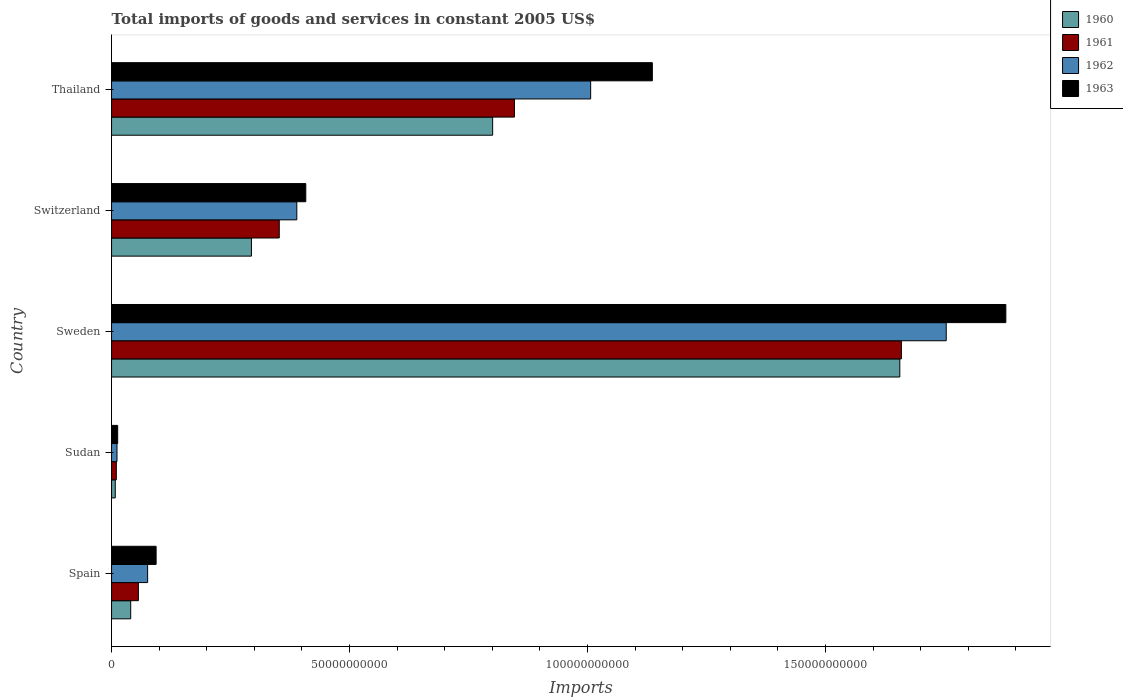How many different coloured bars are there?
Your answer should be very brief. 4. How many groups of bars are there?
Your answer should be compact. 5. Are the number of bars on each tick of the Y-axis equal?
Your response must be concise. Yes. How many bars are there on the 4th tick from the bottom?
Make the answer very short. 4. What is the label of the 1st group of bars from the top?
Your answer should be very brief. Thailand. What is the total imports of goods and services in 1960 in Sweden?
Offer a very short reply. 1.66e+11. Across all countries, what is the maximum total imports of goods and services in 1963?
Ensure brevity in your answer.  1.88e+11. Across all countries, what is the minimum total imports of goods and services in 1961?
Offer a very short reply. 1.00e+09. In which country was the total imports of goods and services in 1960 maximum?
Ensure brevity in your answer.  Sweden. In which country was the total imports of goods and services in 1961 minimum?
Keep it short and to the point. Sudan. What is the total total imports of goods and services in 1963 in the graph?
Offer a terse response. 3.53e+11. What is the difference between the total imports of goods and services in 1960 in Spain and that in Sudan?
Your answer should be compact. 3.24e+09. What is the difference between the total imports of goods and services in 1962 in Sudan and the total imports of goods and services in 1960 in Switzerland?
Ensure brevity in your answer.  -2.82e+1. What is the average total imports of goods and services in 1962 per country?
Your answer should be very brief. 6.47e+1. What is the difference between the total imports of goods and services in 1962 and total imports of goods and services in 1963 in Thailand?
Keep it short and to the point. -1.30e+1. In how many countries, is the total imports of goods and services in 1960 greater than 160000000000 US$?
Your response must be concise. 1. What is the ratio of the total imports of goods and services in 1963 in Sweden to that in Thailand?
Keep it short and to the point. 1.65. What is the difference between the highest and the second highest total imports of goods and services in 1962?
Make the answer very short. 7.47e+1. What is the difference between the highest and the lowest total imports of goods and services in 1963?
Your response must be concise. 1.87e+11. In how many countries, is the total imports of goods and services in 1960 greater than the average total imports of goods and services in 1960 taken over all countries?
Keep it short and to the point. 2. Is it the case that in every country, the sum of the total imports of goods and services in 1961 and total imports of goods and services in 1960 is greater than the sum of total imports of goods and services in 1963 and total imports of goods and services in 1962?
Offer a very short reply. No. How many bars are there?
Ensure brevity in your answer.  20. Are the values on the major ticks of X-axis written in scientific E-notation?
Keep it short and to the point. No. Does the graph contain any zero values?
Keep it short and to the point. No. Where does the legend appear in the graph?
Your response must be concise. Top right. How are the legend labels stacked?
Make the answer very short. Vertical. What is the title of the graph?
Provide a short and direct response. Total imports of goods and services in constant 2005 US$. What is the label or title of the X-axis?
Keep it short and to the point. Imports. What is the Imports in 1960 in Spain?
Make the answer very short. 4.02e+09. What is the Imports of 1961 in Spain?
Keep it short and to the point. 5.64e+09. What is the Imports of 1962 in Spain?
Ensure brevity in your answer.  7.58e+09. What is the Imports of 1963 in Spain?
Your answer should be compact. 9.36e+09. What is the Imports of 1960 in Sudan?
Give a very brief answer. 7.79e+08. What is the Imports of 1961 in Sudan?
Your response must be concise. 1.00e+09. What is the Imports of 1962 in Sudan?
Offer a very short reply. 1.14e+09. What is the Imports of 1963 in Sudan?
Offer a very short reply. 1.28e+09. What is the Imports in 1960 in Sweden?
Give a very brief answer. 1.66e+11. What is the Imports in 1961 in Sweden?
Keep it short and to the point. 1.66e+11. What is the Imports of 1962 in Sweden?
Your answer should be very brief. 1.75e+11. What is the Imports of 1963 in Sweden?
Give a very brief answer. 1.88e+11. What is the Imports in 1960 in Switzerland?
Make the answer very short. 2.94e+1. What is the Imports of 1961 in Switzerland?
Your answer should be compact. 3.52e+1. What is the Imports of 1962 in Switzerland?
Make the answer very short. 3.89e+1. What is the Imports of 1963 in Switzerland?
Your response must be concise. 4.08e+1. What is the Imports in 1960 in Thailand?
Ensure brevity in your answer.  8.01e+1. What is the Imports of 1961 in Thailand?
Offer a terse response. 8.46e+1. What is the Imports in 1962 in Thailand?
Make the answer very short. 1.01e+11. What is the Imports in 1963 in Thailand?
Your response must be concise. 1.14e+11. Across all countries, what is the maximum Imports in 1960?
Provide a succinct answer. 1.66e+11. Across all countries, what is the maximum Imports of 1961?
Ensure brevity in your answer.  1.66e+11. Across all countries, what is the maximum Imports of 1962?
Ensure brevity in your answer.  1.75e+11. Across all countries, what is the maximum Imports in 1963?
Offer a terse response. 1.88e+11. Across all countries, what is the minimum Imports of 1960?
Your answer should be compact. 7.79e+08. Across all countries, what is the minimum Imports in 1961?
Offer a very short reply. 1.00e+09. Across all countries, what is the minimum Imports in 1962?
Make the answer very short. 1.14e+09. Across all countries, what is the minimum Imports in 1963?
Your answer should be very brief. 1.28e+09. What is the total Imports of 1960 in the graph?
Offer a very short reply. 2.80e+11. What is the total Imports in 1961 in the graph?
Offer a terse response. 2.92e+11. What is the total Imports of 1962 in the graph?
Provide a succinct answer. 3.24e+11. What is the total Imports in 1963 in the graph?
Provide a succinct answer. 3.53e+11. What is the difference between the Imports in 1960 in Spain and that in Sudan?
Keep it short and to the point. 3.24e+09. What is the difference between the Imports in 1961 in Spain and that in Sudan?
Your answer should be compact. 4.63e+09. What is the difference between the Imports in 1962 in Spain and that in Sudan?
Your answer should be very brief. 6.44e+09. What is the difference between the Imports in 1963 in Spain and that in Sudan?
Give a very brief answer. 8.08e+09. What is the difference between the Imports of 1960 in Spain and that in Sweden?
Your response must be concise. -1.62e+11. What is the difference between the Imports of 1961 in Spain and that in Sweden?
Provide a succinct answer. -1.60e+11. What is the difference between the Imports of 1962 in Spain and that in Sweden?
Ensure brevity in your answer.  -1.68e+11. What is the difference between the Imports of 1963 in Spain and that in Sweden?
Offer a terse response. -1.79e+11. What is the difference between the Imports in 1960 in Spain and that in Switzerland?
Offer a terse response. -2.54e+1. What is the difference between the Imports of 1961 in Spain and that in Switzerland?
Offer a very short reply. -2.96e+1. What is the difference between the Imports of 1962 in Spain and that in Switzerland?
Make the answer very short. -3.13e+1. What is the difference between the Imports of 1963 in Spain and that in Switzerland?
Give a very brief answer. -3.14e+1. What is the difference between the Imports in 1960 in Spain and that in Thailand?
Provide a short and direct response. -7.60e+1. What is the difference between the Imports of 1961 in Spain and that in Thailand?
Offer a terse response. -7.90e+1. What is the difference between the Imports of 1962 in Spain and that in Thailand?
Offer a very short reply. -9.31e+1. What is the difference between the Imports of 1963 in Spain and that in Thailand?
Your answer should be compact. -1.04e+11. What is the difference between the Imports in 1960 in Sudan and that in Sweden?
Provide a succinct answer. -1.65e+11. What is the difference between the Imports of 1961 in Sudan and that in Sweden?
Offer a very short reply. -1.65e+11. What is the difference between the Imports in 1962 in Sudan and that in Sweden?
Keep it short and to the point. -1.74e+11. What is the difference between the Imports of 1963 in Sudan and that in Sweden?
Provide a succinct answer. -1.87e+11. What is the difference between the Imports in 1960 in Sudan and that in Switzerland?
Your response must be concise. -2.86e+1. What is the difference between the Imports in 1961 in Sudan and that in Switzerland?
Make the answer very short. -3.42e+1. What is the difference between the Imports in 1962 in Sudan and that in Switzerland?
Your answer should be compact. -3.78e+1. What is the difference between the Imports of 1963 in Sudan and that in Switzerland?
Your answer should be very brief. -3.95e+1. What is the difference between the Imports in 1960 in Sudan and that in Thailand?
Keep it short and to the point. -7.93e+1. What is the difference between the Imports of 1961 in Sudan and that in Thailand?
Offer a terse response. -8.36e+1. What is the difference between the Imports of 1962 in Sudan and that in Thailand?
Your answer should be compact. -9.95e+1. What is the difference between the Imports of 1963 in Sudan and that in Thailand?
Offer a terse response. -1.12e+11. What is the difference between the Imports of 1960 in Sweden and that in Switzerland?
Give a very brief answer. 1.36e+11. What is the difference between the Imports of 1961 in Sweden and that in Switzerland?
Offer a terse response. 1.31e+11. What is the difference between the Imports of 1962 in Sweden and that in Switzerland?
Offer a very short reply. 1.36e+11. What is the difference between the Imports of 1963 in Sweden and that in Switzerland?
Provide a succinct answer. 1.47e+11. What is the difference between the Imports in 1960 in Sweden and that in Thailand?
Ensure brevity in your answer.  8.55e+1. What is the difference between the Imports in 1961 in Sweden and that in Thailand?
Make the answer very short. 8.13e+1. What is the difference between the Imports of 1962 in Sweden and that in Thailand?
Your answer should be very brief. 7.47e+1. What is the difference between the Imports of 1963 in Sweden and that in Thailand?
Give a very brief answer. 7.43e+1. What is the difference between the Imports of 1960 in Switzerland and that in Thailand?
Your answer should be very brief. -5.07e+1. What is the difference between the Imports in 1961 in Switzerland and that in Thailand?
Your answer should be very brief. -4.94e+1. What is the difference between the Imports in 1962 in Switzerland and that in Thailand?
Your answer should be very brief. -6.17e+1. What is the difference between the Imports of 1963 in Switzerland and that in Thailand?
Your answer should be very brief. -7.28e+1. What is the difference between the Imports in 1960 in Spain and the Imports in 1961 in Sudan?
Provide a succinct answer. 3.02e+09. What is the difference between the Imports in 1960 in Spain and the Imports in 1962 in Sudan?
Keep it short and to the point. 2.88e+09. What is the difference between the Imports in 1960 in Spain and the Imports in 1963 in Sudan?
Keep it short and to the point. 2.74e+09. What is the difference between the Imports in 1961 in Spain and the Imports in 1962 in Sudan?
Your answer should be very brief. 4.49e+09. What is the difference between the Imports of 1961 in Spain and the Imports of 1963 in Sudan?
Ensure brevity in your answer.  4.35e+09. What is the difference between the Imports in 1962 in Spain and the Imports in 1963 in Sudan?
Provide a short and direct response. 6.30e+09. What is the difference between the Imports of 1960 in Spain and the Imports of 1961 in Sweden?
Your answer should be compact. -1.62e+11. What is the difference between the Imports of 1960 in Spain and the Imports of 1962 in Sweden?
Offer a terse response. -1.71e+11. What is the difference between the Imports of 1960 in Spain and the Imports of 1963 in Sweden?
Your response must be concise. -1.84e+11. What is the difference between the Imports of 1961 in Spain and the Imports of 1962 in Sweden?
Offer a terse response. -1.70e+11. What is the difference between the Imports in 1961 in Spain and the Imports in 1963 in Sweden?
Give a very brief answer. -1.82e+11. What is the difference between the Imports in 1962 in Spain and the Imports in 1963 in Sweden?
Keep it short and to the point. -1.80e+11. What is the difference between the Imports of 1960 in Spain and the Imports of 1961 in Switzerland?
Provide a succinct answer. -3.12e+1. What is the difference between the Imports in 1960 in Spain and the Imports in 1962 in Switzerland?
Give a very brief answer. -3.49e+1. What is the difference between the Imports of 1960 in Spain and the Imports of 1963 in Switzerland?
Offer a very short reply. -3.68e+1. What is the difference between the Imports in 1961 in Spain and the Imports in 1962 in Switzerland?
Offer a terse response. -3.33e+1. What is the difference between the Imports of 1961 in Spain and the Imports of 1963 in Switzerland?
Make the answer very short. -3.52e+1. What is the difference between the Imports in 1962 in Spain and the Imports in 1963 in Switzerland?
Ensure brevity in your answer.  -3.32e+1. What is the difference between the Imports in 1960 in Spain and the Imports in 1961 in Thailand?
Offer a terse response. -8.06e+1. What is the difference between the Imports in 1960 in Spain and the Imports in 1962 in Thailand?
Your response must be concise. -9.66e+1. What is the difference between the Imports of 1960 in Spain and the Imports of 1963 in Thailand?
Ensure brevity in your answer.  -1.10e+11. What is the difference between the Imports in 1961 in Spain and the Imports in 1962 in Thailand?
Ensure brevity in your answer.  -9.50e+1. What is the difference between the Imports in 1961 in Spain and the Imports in 1963 in Thailand?
Ensure brevity in your answer.  -1.08e+11. What is the difference between the Imports in 1962 in Spain and the Imports in 1963 in Thailand?
Make the answer very short. -1.06e+11. What is the difference between the Imports in 1960 in Sudan and the Imports in 1961 in Sweden?
Your answer should be compact. -1.65e+11. What is the difference between the Imports in 1960 in Sudan and the Imports in 1962 in Sweden?
Make the answer very short. -1.75e+11. What is the difference between the Imports in 1960 in Sudan and the Imports in 1963 in Sweden?
Keep it short and to the point. -1.87e+11. What is the difference between the Imports in 1961 in Sudan and the Imports in 1962 in Sweden?
Give a very brief answer. -1.74e+11. What is the difference between the Imports in 1961 in Sudan and the Imports in 1963 in Sweden?
Your answer should be compact. -1.87e+11. What is the difference between the Imports of 1962 in Sudan and the Imports of 1963 in Sweden?
Give a very brief answer. -1.87e+11. What is the difference between the Imports of 1960 in Sudan and the Imports of 1961 in Switzerland?
Offer a very short reply. -3.45e+1. What is the difference between the Imports of 1960 in Sudan and the Imports of 1962 in Switzerland?
Provide a succinct answer. -3.81e+1. What is the difference between the Imports in 1960 in Sudan and the Imports in 1963 in Switzerland?
Your answer should be compact. -4.00e+1. What is the difference between the Imports of 1961 in Sudan and the Imports of 1962 in Switzerland?
Provide a short and direct response. -3.79e+1. What is the difference between the Imports of 1961 in Sudan and the Imports of 1963 in Switzerland?
Provide a short and direct response. -3.98e+1. What is the difference between the Imports of 1962 in Sudan and the Imports of 1963 in Switzerland?
Your answer should be very brief. -3.97e+1. What is the difference between the Imports of 1960 in Sudan and the Imports of 1961 in Thailand?
Keep it short and to the point. -8.39e+1. What is the difference between the Imports in 1960 in Sudan and the Imports in 1962 in Thailand?
Provide a short and direct response. -9.99e+1. What is the difference between the Imports of 1960 in Sudan and the Imports of 1963 in Thailand?
Ensure brevity in your answer.  -1.13e+11. What is the difference between the Imports in 1961 in Sudan and the Imports in 1962 in Thailand?
Offer a terse response. -9.97e+1. What is the difference between the Imports in 1961 in Sudan and the Imports in 1963 in Thailand?
Your response must be concise. -1.13e+11. What is the difference between the Imports in 1962 in Sudan and the Imports in 1963 in Thailand?
Provide a short and direct response. -1.12e+11. What is the difference between the Imports in 1960 in Sweden and the Imports in 1961 in Switzerland?
Offer a very short reply. 1.30e+11. What is the difference between the Imports in 1960 in Sweden and the Imports in 1962 in Switzerland?
Your answer should be compact. 1.27e+11. What is the difference between the Imports of 1960 in Sweden and the Imports of 1963 in Switzerland?
Your answer should be very brief. 1.25e+11. What is the difference between the Imports in 1961 in Sweden and the Imports in 1962 in Switzerland?
Make the answer very short. 1.27e+11. What is the difference between the Imports in 1961 in Sweden and the Imports in 1963 in Switzerland?
Your answer should be very brief. 1.25e+11. What is the difference between the Imports of 1962 in Sweden and the Imports of 1963 in Switzerland?
Your response must be concise. 1.35e+11. What is the difference between the Imports in 1960 in Sweden and the Imports in 1961 in Thailand?
Provide a succinct answer. 8.10e+1. What is the difference between the Imports of 1960 in Sweden and the Imports of 1962 in Thailand?
Your answer should be very brief. 6.50e+1. What is the difference between the Imports in 1960 in Sweden and the Imports in 1963 in Thailand?
Your answer should be very brief. 5.20e+1. What is the difference between the Imports in 1961 in Sweden and the Imports in 1962 in Thailand?
Offer a terse response. 6.53e+1. What is the difference between the Imports in 1961 in Sweden and the Imports in 1963 in Thailand?
Give a very brief answer. 5.23e+1. What is the difference between the Imports of 1962 in Sweden and the Imports of 1963 in Thailand?
Your answer should be very brief. 6.17e+1. What is the difference between the Imports in 1960 in Switzerland and the Imports in 1961 in Thailand?
Make the answer very short. -5.53e+1. What is the difference between the Imports in 1960 in Switzerland and the Imports in 1962 in Thailand?
Provide a succinct answer. -7.13e+1. What is the difference between the Imports in 1960 in Switzerland and the Imports in 1963 in Thailand?
Offer a very short reply. -8.42e+1. What is the difference between the Imports of 1961 in Switzerland and the Imports of 1962 in Thailand?
Provide a short and direct response. -6.54e+1. What is the difference between the Imports of 1961 in Switzerland and the Imports of 1963 in Thailand?
Make the answer very short. -7.84e+1. What is the difference between the Imports of 1962 in Switzerland and the Imports of 1963 in Thailand?
Your answer should be very brief. -7.47e+1. What is the average Imports of 1960 per country?
Offer a terse response. 5.60e+1. What is the average Imports of 1961 per country?
Your answer should be very brief. 5.85e+1. What is the average Imports of 1962 per country?
Your response must be concise. 6.47e+1. What is the average Imports in 1963 per country?
Offer a terse response. 7.06e+1. What is the difference between the Imports in 1960 and Imports in 1961 in Spain?
Give a very brief answer. -1.61e+09. What is the difference between the Imports in 1960 and Imports in 1962 in Spain?
Your answer should be very brief. -3.56e+09. What is the difference between the Imports of 1960 and Imports of 1963 in Spain?
Your answer should be compact. -5.34e+09. What is the difference between the Imports of 1961 and Imports of 1962 in Spain?
Offer a very short reply. -1.94e+09. What is the difference between the Imports in 1961 and Imports in 1963 in Spain?
Make the answer very short. -3.72e+09. What is the difference between the Imports of 1962 and Imports of 1963 in Spain?
Offer a very short reply. -1.78e+09. What is the difference between the Imports of 1960 and Imports of 1961 in Sudan?
Your answer should be very brief. -2.25e+08. What is the difference between the Imports of 1960 and Imports of 1962 in Sudan?
Keep it short and to the point. -3.65e+08. What is the difference between the Imports in 1960 and Imports in 1963 in Sudan?
Ensure brevity in your answer.  -5.04e+08. What is the difference between the Imports in 1961 and Imports in 1962 in Sudan?
Provide a short and direct response. -1.39e+08. What is the difference between the Imports in 1961 and Imports in 1963 in Sudan?
Provide a succinct answer. -2.79e+08. What is the difference between the Imports in 1962 and Imports in 1963 in Sudan?
Offer a very short reply. -1.39e+08. What is the difference between the Imports in 1960 and Imports in 1961 in Sweden?
Provide a short and direct response. -3.29e+08. What is the difference between the Imports of 1960 and Imports of 1962 in Sweden?
Your response must be concise. -9.75e+09. What is the difference between the Imports of 1960 and Imports of 1963 in Sweden?
Offer a terse response. -2.23e+1. What is the difference between the Imports of 1961 and Imports of 1962 in Sweden?
Make the answer very short. -9.42e+09. What is the difference between the Imports of 1961 and Imports of 1963 in Sweden?
Your answer should be compact. -2.19e+1. What is the difference between the Imports in 1962 and Imports in 1963 in Sweden?
Offer a very short reply. -1.25e+1. What is the difference between the Imports of 1960 and Imports of 1961 in Switzerland?
Provide a succinct answer. -5.85e+09. What is the difference between the Imports of 1960 and Imports of 1962 in Switzerland?
Make the answer very short. -9.53e+09. What is the difference between the Imports of 1960 and Imports of 1963 in Switzerland?
Your answer should be very brief. -1.14e+1. What is the difference between the Imports of 1961 and Imports of 1962 in Switzerland?
Your answer should be compact. -3.69e+09. What is the difference between the Imports in 1961 and Imports in 1963 in Switzerland?
Provide a succinct answer. -5.57e+09. What is the difference between the Imports in 1962 and Imports in 1963 in Switzerland?
Make the answer very short. -1.88e+09. What is the difference between the Imports of 1960 and Imports of 1961 in Thailand?
Ensure brevity in your answer.  -4.58e+09. What is the difference between the Imports of 1960 and Imports of 1962 in Thailand?
Offer a terse response. -2.06e+1. What is the difference between the Imports in 1960 and Imports in 1963 in Thailand?
Provide a succinct answer. -3.36e+1. What is the difference between the Imports of 1961 and Imports of 1962 in Thailand?
Keep it short and to the point. -1.60e+1. What is the difference between the Imports in 1961 and Imports in 1963 in Thailand?
Offer a terse response. -2.90e+1. What is the difference between the Imports in 1962 and Imports in 1963 in Thailand?
Provide a short and direct response. -1.30e+1. What is the ratio of the Imports in 1960 in Spain to that in Sudan?
Keep it short and to the point. 5.16. What is the ratio of the Imports of 1961 in Spain to that in Sudan?
Keep it short and to the point. 5.61. What is the ratio of the Imports of 1962 in Spain to that in Sudan?
Offer a terse response. 6.63. What is the ratio of the Imports of 1963 in Spain to that in Sudan?
Your answer should be compact. 7.3. What is the ratio of the Imports of 1960 in Spain to that in Sweden?
Give a very brief answer. 0.02. What is the ratio of the Imports in 1961 in Spain to that in Sweden?
Ensure brevity in your answer.  0.03. What is the ratio of the Imports in 1962 in Spain to that in Sweden?
Provide a short and direct response. 0.04. What is the ratio of the Imports of 1963 in Spain to that in Sweden?
Provide a succinct answer. 0.05. What is the ratio of the Imports in 1960 in Spain to that in Switzerland?
Offer a very short reply. 0.14. What is the ratio of the Imports in 1961 in Spain to that in Switzerland?
Your response must be concise. 0.16. What is the ratio of the Imports of 1962 in Spain to that in Switzerland?
Make the answer very short. 0.19. What is the ratio of the Imports in 1963 in Spain to that in Switzerland?
Your response must be concise. 0.23. What is the ratio of the Imports in 1960 in Spain to that in Thailand?
Provide a succinct answer. 0.05. What is the ratio of the Imports of 1961 in Spain to that in Thailand?
Your response must be concise. 0.07. What is the ratio of the Imports of 1962 in Spain to that in Thailand?
Offer a terse response. 0.08. What is the ratio of the Imports of 1963 in Spain to that in Thailand?
Offer a very short reply. 0.08. What is the ratio of the Imports of 1960 in Sudan to that in Sweden?
Your answer should be very brief. 0. What is the ratio of the Imports of 1961 in Sudan to that in Sweden?
Give a very brief answer. 0.01. What is the ratio of the Imports in 1962 in Sudan to that in Sweden?
Keep it short and to the point. 0.01. What is the ratio of the Imports in 1963 in Sudan to that in Sweden?
Your answer should be compact. 0.01. What is the ratio of the Imports of 1960 in Sudan to that in Switzerland?
Provide a succinct answer. 0.03. What is the ratio of the Imports of 1961 in Sudan to that in Switzerland?
Your response must be concise. 0.03. What is the ratio of the Imports in 1962 in Sudan to that in Switzerland?
Offer a very short reply. 0.03. What is the ratio of the Imports in 1963 in Sudan to that in Switzerland?
Your answer should be compact. 0.03. What is the ratio of the Imports in 1960 in Sudan to that in Thailand?
Keep it short and to the point. 0.01. What is the ratio of the Imports of 1961 in Sudan to that in Thailand?
Give a very brief answer. 0.01. What is the ratio of the Imports in 1962 in Sudan to that in Thailand?
Keep it short and to the point. 0.01. What is the ratio of the Imports in 1963 in Sudan to that in Thailand?
Provide a short and direct response. 0.01. What is the ratio of the Imports in 1960 in Sweden to that in Switzerland?
Ensure brevity in your answer.  5.64. What is the ratio of the Imports of 1961 in Sweden to that in Switzerland?
Your answer should be very brief. 4.71. What is the ratio of the Imports of 1962 in Sweden to that in Switzerland?
Provide a short and direct response. 4.51. What is the ratio of the Imports of 1963 in Sweden to that in Switzerland?
Offer a very short reply. 4.6. What is the ratio of the Imports of 1960 in Sweden to that in Thailand?
Your response must be concise. 2.07. What is the ratio of the Imports of 1961 in Sweden to that in Thailand?
Your answer should be compact. 1.96. What is the ratio of the Imports in 1962 in Sweden to that in Thailand?
Give a very brief answer. 1.74. What is the ratio of the Imports of 1963 in Sweden to that in Thailand?
Your answer should be very brief. 1.65. What is the ratio of the Imports in 1960 in Switzerland to that in Thailand?
Your answer should be compact. 0.37. What is the ratio of the Imports of 1961 in Switzerland to that in Thailand?
Your answer should be compact. 0.42. What is the ratio of the Imports of 1962 in Switzerland to that in Thailand?
Provide a succinct answer. 0.39. What is the ratio of the Imports in 1963 in Switzerland to that in Thailand?
Your answer should be very brief. 0.36. What is the difference between the highest and the second highest Imports in 1960?
Provide a short and direct response. 8.55e+1. What is the difference between the highest and the second highest Imports in 1961?
Your response must be concise. 8.13e+1. What is the difference between the highest and the second highest Imports of 1962?
Your response must be concise. 7.47e+1. What is the difference between the highest and the second highest Imports in 1963?
Offer a very short reply. 7.43e+1. What is the difference between the highest and the lowest Imports in 1960?
Offer a very short reply. 1.65e+11. What is the difference between the highest and the lowest Imports of 1961?
Offer a very short reply. 1.65e+11. What is the difference between the highest and the lowest Imports in 1962?
Offer a terse response. 1.74e+11. What is the difference between the highest and the lowest Imports in 1963?
Your answer should be very brief. 1.87e+11. 